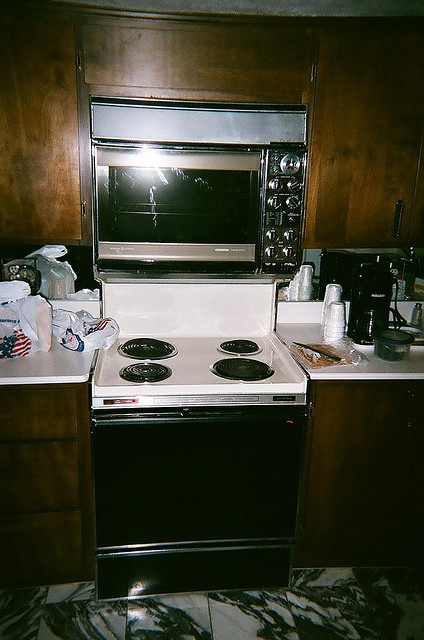Describe the objects in this image and their specific colors. I can see oven in black, lightgray, darkgray, and gray tones, microwave in black, gray, lightgray, and darkgray tones, bowl in black, gray, and darkgreen tones, cup in black, lightgray, darkgray, and gray tones, and cup in black, lightgray, darkgray, and gray tones in this image. 